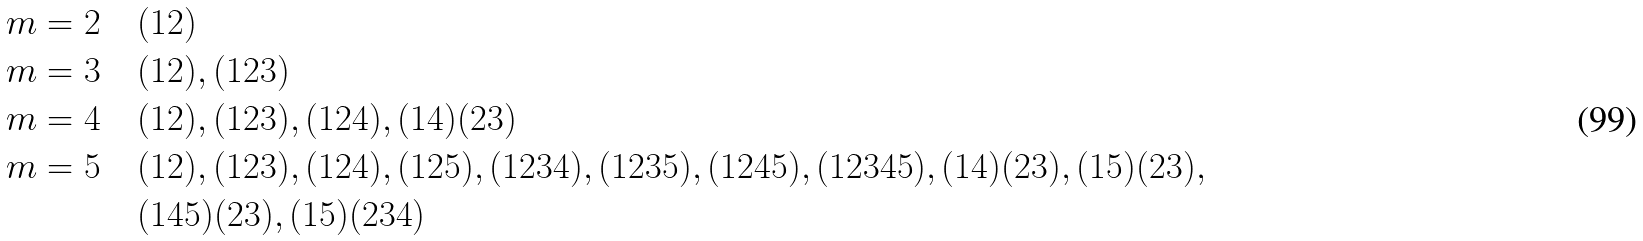Convert formula to latex. <formula><loc_0><loc_0><loc_500><loc_500>m = 2 \quad & ( 1 2 ) \\ m = 3 \quad & ( 1 2 ) , ( 1 2 3 ) \\ m = 4 \quad & ( 1 2 ) , ( 1 2 3 ) , ( 1 2 4 ) , ( 1 4 ) ( 2 3 ) \\ m = 5 \quad & ( 1 2 ) , ( 1 2 3 ) , ( 1 2 4 ) , ( 1 2 5 ) , ( 1 2 3 4 ) , ( 1 2 3 5 ) , ( 1 2 4 5 ) , ( 1 2 3 4 5 ) , ( 1 4 ) ( 2 3 ) , ( 1 5 ) ( 2 3 ) , \\ & ( 1 4 5 ) ( 2 3 ) , ( 1 5 ) ( 2 3 4 )</formula> 